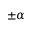Convert formula to latex. <formula><loc_0><loc_0><loc_500><loc_500>\pm \alpha</formula> 